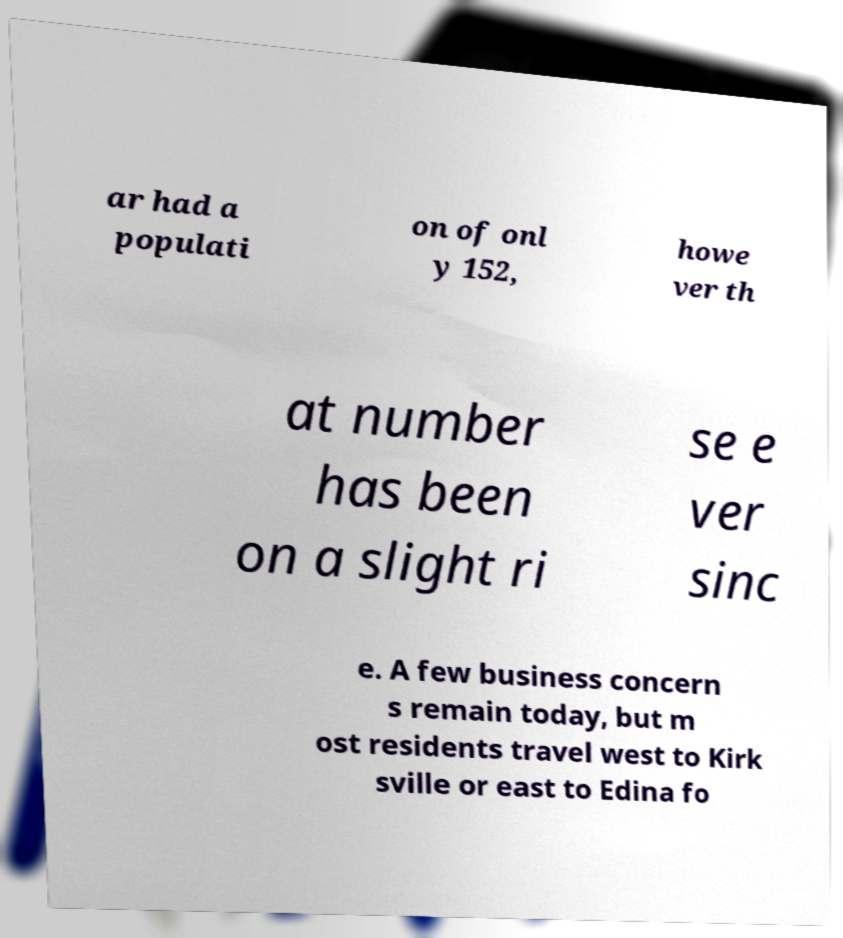Please read and relay the text visible in this image. What does it say? ar had a populati on of onl y 152, howe ver th at number has been on a slight ri se e ver sinc e. A few business concern s remain today, but m ost residents travel west to Kirk sville or east to Edina fo 